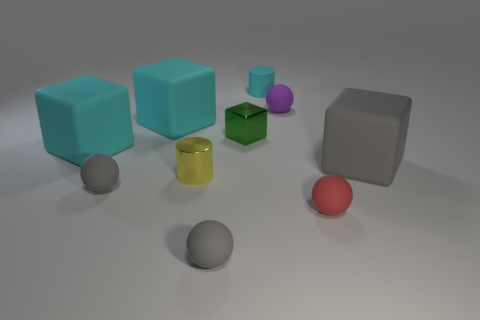Subtract all gray spheres. How many cyan blocks are left? 2 Subtract all purple spheres. How many spheres are left? 3 Subtract all cubes. How many objects are left? 6 Subtract 1 cylinders. How many cylinders are left? 1 Subtract all gray cubes. How many cubes are left? 3 Add 4 small yellow metal cylinders. How many small yellow metal cylinders exist? 5 Subtract 0 green cylinders. How many objects are left? 10 Subtract all yellow cylinders. Subtract all red blocks. How many cylinders are left? 1 Subtract all big purple matte blocks. Subtract all red matte things. How many objects are left? 9 Add 8 yellow cylinders. How many yellow cylinders are left? 9 